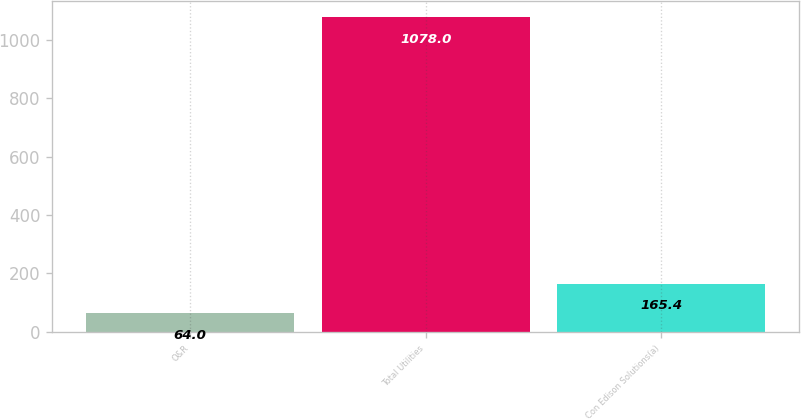Convert chart to OTSL. <chart><loc_0><loc_0><loc_500><loc_500><bar_chart><fcel>O&R<fcel>Total Utilities<fcel>Con Edison Solutions(a)<nl><fcel>64<fcel>1078<fcel>165.4<nl></chart> 